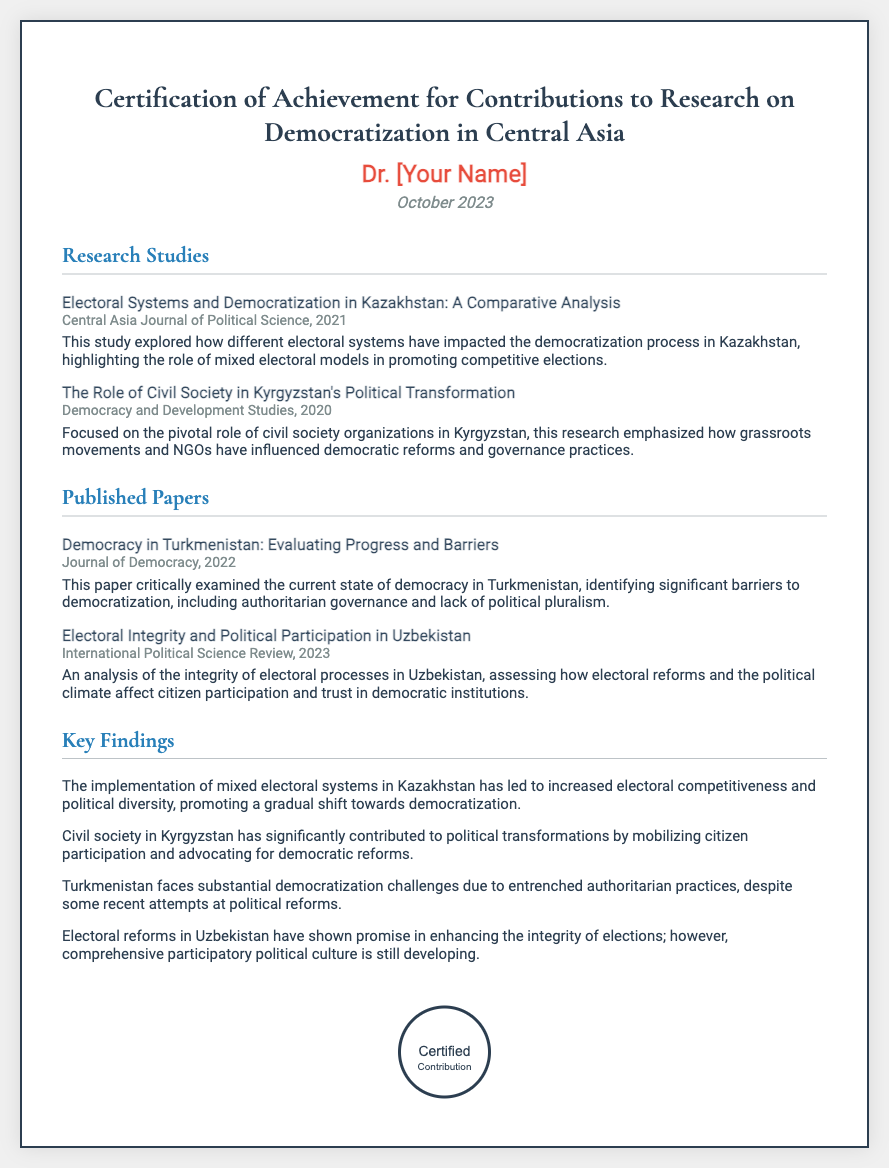What is the title of the certificate? The title of the certificate is explicitly mentioned at the top of the document.
Answer: Certification of Achievement for Contributions to Research on Democratization in Central Asia Who is the recipient of the certificate? The recipient's name is displayed prominently on the certificate.
Answer: Dr. [Your Name] What is the date on the certificate? The date is indicated in the document underneath the recipient's name.
Answer: October 2023 What is the title of the study published in 2021? The title is listed under the Research Studies section with the publication year.
Answer: Electoral Systems and Democratization in Kazakhstan: A Comparative Analysis What key finding relates to Kazakhstan's electoral system? This finding involves the analysis of mixed electoral systems in Kazakhstan.
Answer: Increased electoral competitiveness and political diversity Which paper discusses democracy in Turkmenistan? The paper's title can be found under the Published Papers section with its publication details.
Answer: Democracy in Turkmenistan: Evaluating Progress and Barriers What is emphasized as a significant barrier to democratization in Turkmenistan? This information is found in the key findings and summarizes current challenges.
Answer: Authoritarian governance What organization type is central to Kyrgyzstan's political transformation? The document highlights the role of specific organizations in the related study.
Answer: Civil society organizations 